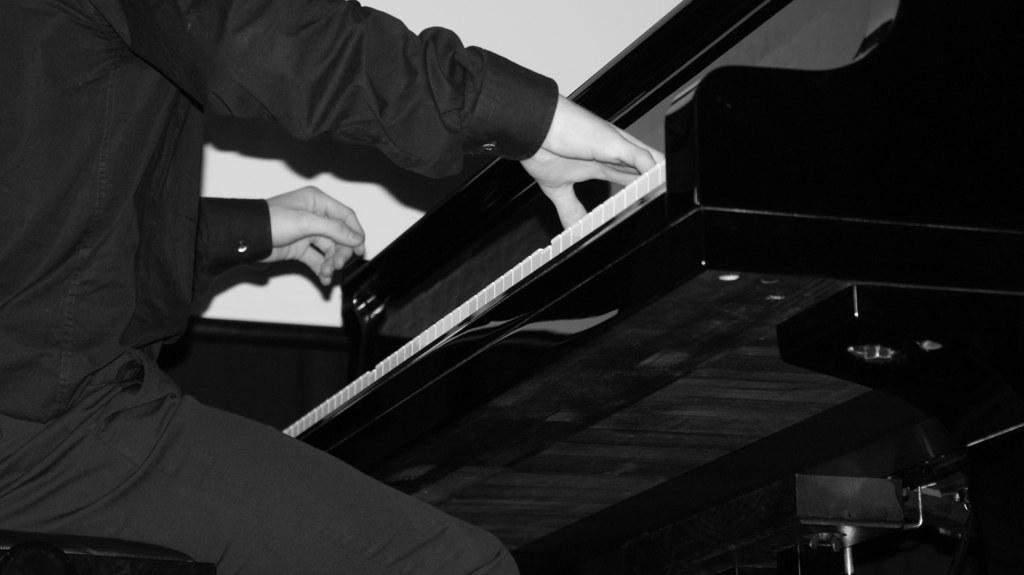Can you describe this image briefly? There is a person sitting and playing piano. 